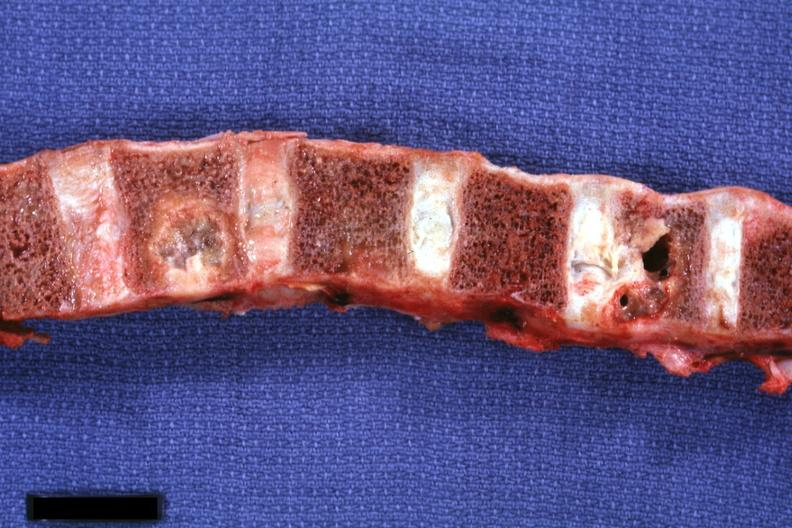how is vertebral bodies showing very nicely osteolytic metastatic lesions squamous cell carcinoma penis?
Answer the question using a single word or phrase. Primary 